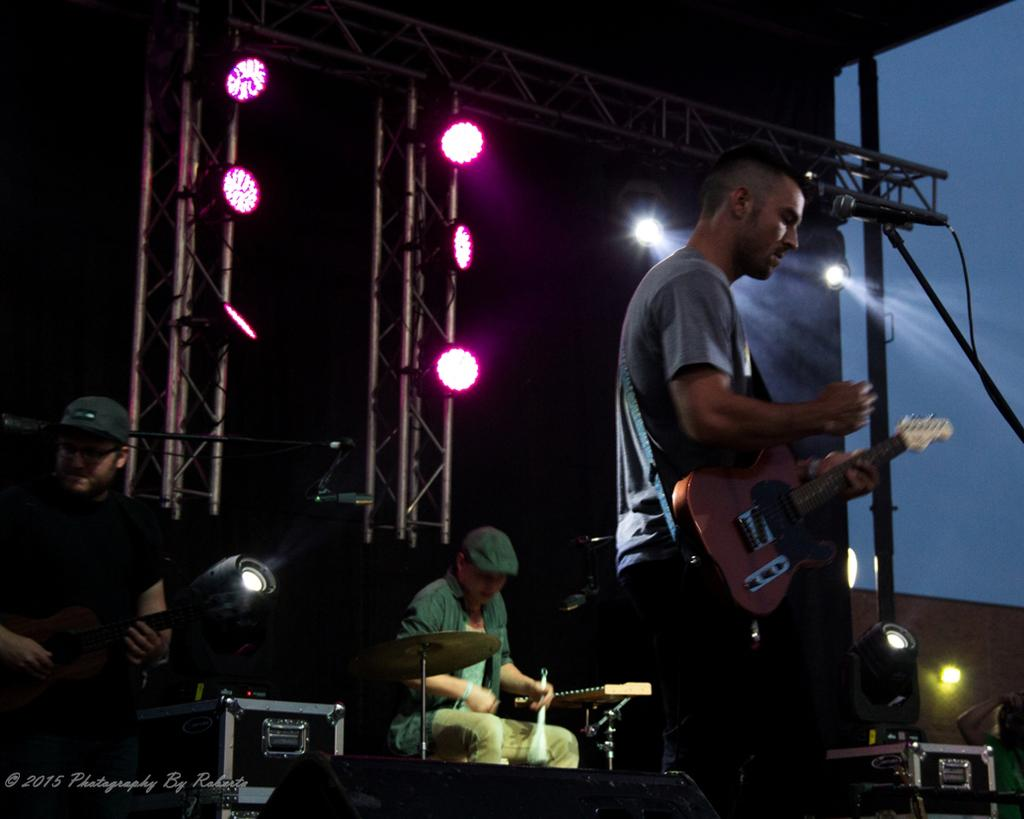How many people are on stage in the image? There are three men on stage in the image. What instruments are being played by the men on stage? One man is playing a guitar, and another is playing drums. What is the person on stage doing? A person is singing on a microphone. What can be seen in the background of the image? There are lights on a pillar in the background. Are there any visible cobwebs on the microphone in the image? There is no mention of cobwebs in the image, and therefore it cannot be determined if any are present on the microphone. 